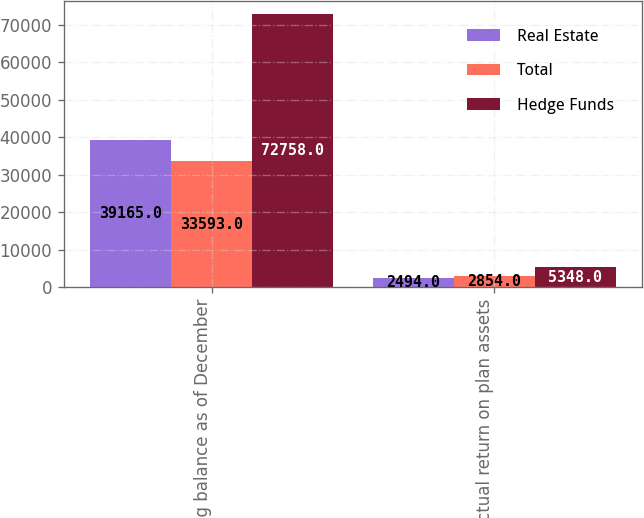Convert chart. <chart><loc_0><loc_0><loc_500><loc_500><stacked_bar_chart><ecel><fcel>Ending balance as of December<fcel>Actual return on plan assets<nl><fcel>Real Estate<fcel>39165<fcel>2494<nl><fcel>Total<fcel>33593<fcel>2854<nl><fcel>Hedge Funds<fcel>72758<fcel>5348<nl></chart> 